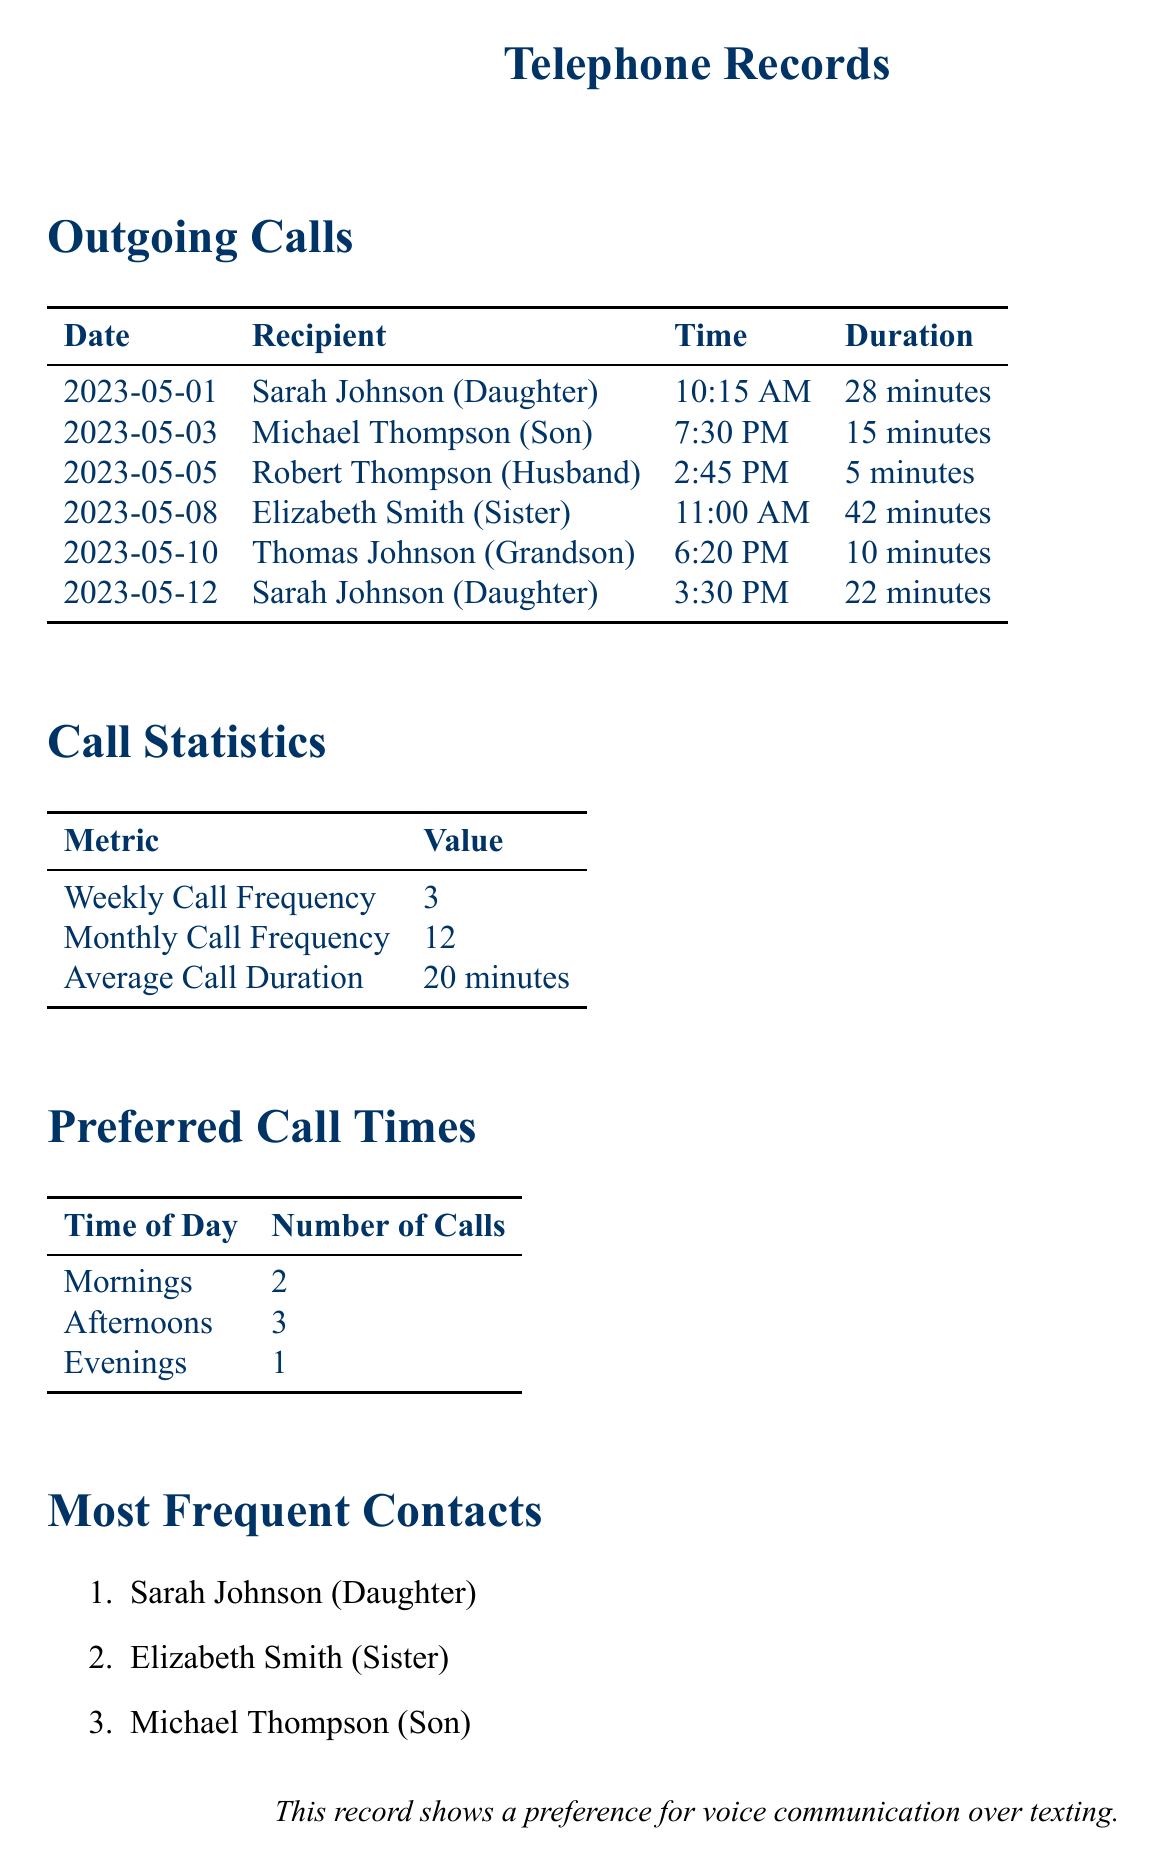What is the average call duration? The average call duration is mentioned in the call statistics section, calculated from all outgoing calls.
Answer: 20 minutes How many times did Sarah Johnson receive calls? Sarah Johnson is listed as a recipient in two outgoing calls in the document.
Answer: 2 What is the most frequent contact? The most frequent contact is listed in the document under the most frequent contacts section.
Answer: Sarah Johnson (Daughter) When did the call to Elizabeth Smith occur? The date of the call to Elizabeth Smith is specified in the outgoing calls table.
Answer: 2023-05-08 What is the weekly call frequency? The weekly call frequency is provided in the call statistics section of the document.
Answer: 3 Which time of day had the least number of calls? The time category with the least number of calls is indicated in the preferred call times section.
Answer: Evenings How long was the call to Thomas Johnson? The duration of the call to Thomas Johnson is clearly stated in the outgoing calls table.
Answer: 10 minutes How many calls were made in the afternoons? The number of calls made in the afternoons is summarized in the preferred call times table.
Answer: 3 